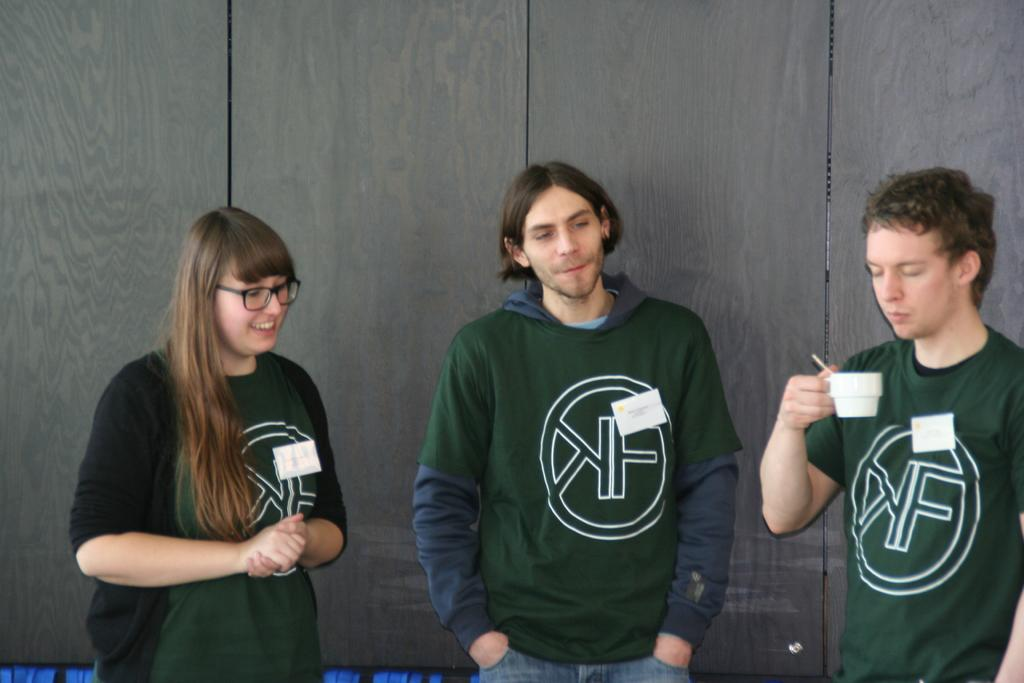How many people are present in the image? There are three persons standing in the image. What is one person holding in their hands? One person is holding a glass in their hands. What can be seen in the background of the image? There is a wooden wall in the background of the image. What type of ticket can be seen in the person's hand in the image? There is no ticket present in the person's hand or in the image. 